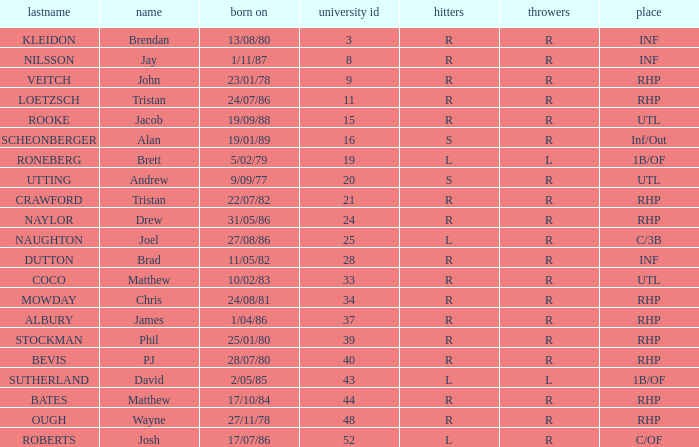Which First has a Uni # larger than 34, and Throws of r, and a Position of rhp, and a Surname of stockman? Phil. 